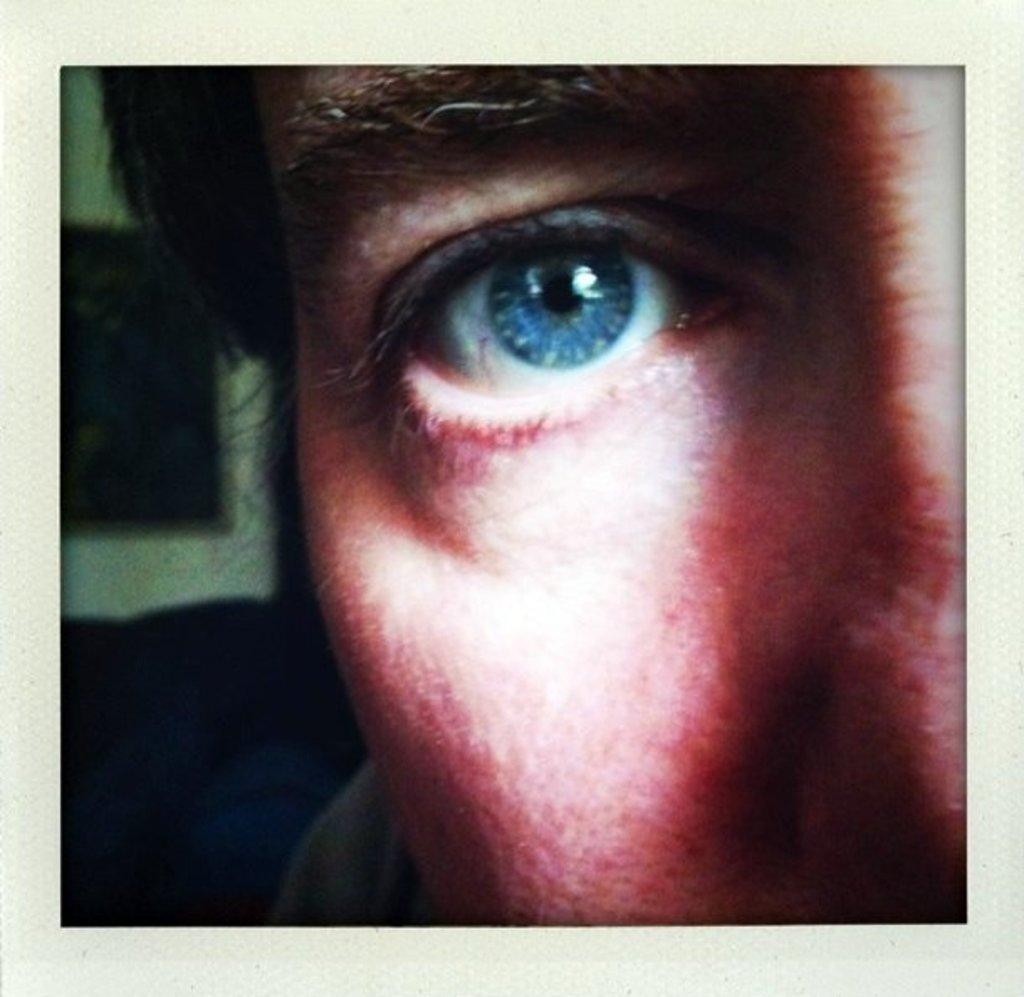What is a notable feature of the person in the image? The person in the image has blue eyes. Where is the person located in the image? The person is in the foreground of the image. What can be seen in the background of the image? There is a frame on the wall in the background of the image. What type of jeans is the person wearing in the image? There is no information about the person's clothing, including jeans, in the image. 